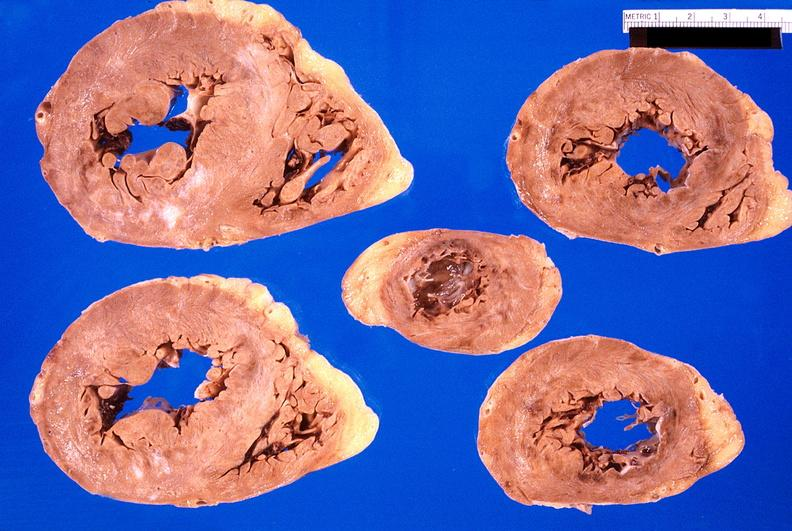what is present?
Answer the question using a single word or phrase. Cardiovascular 